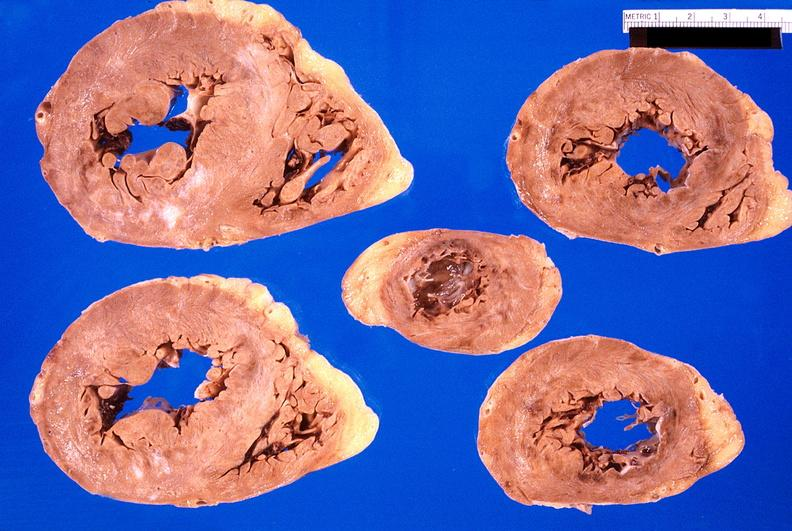what is present?
Answer the question using a single word or phrase. Cardiovascular 